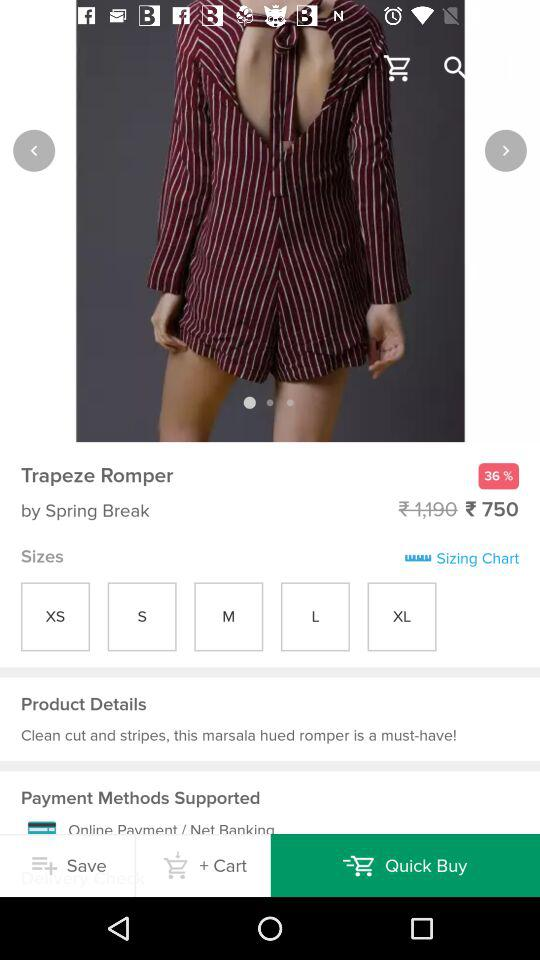What is the price of "Trapeze Romper"? The price is ₹750. 